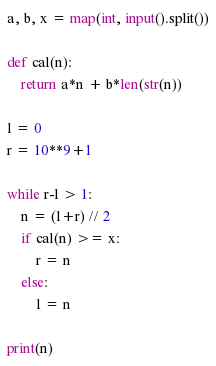<code> <loc_0><loc_0><loc_500><loc_500><_Python_>a, b, x = map(int, input().split())

def cal(n):
    return a*n + b*len(str(n))

l = 0
r = 10**9+1

while r-l > 1:
    n = (l+r) // 2
    if cal(n) >= x:
        r = n
    else:
        l = n

print(n)</code> 